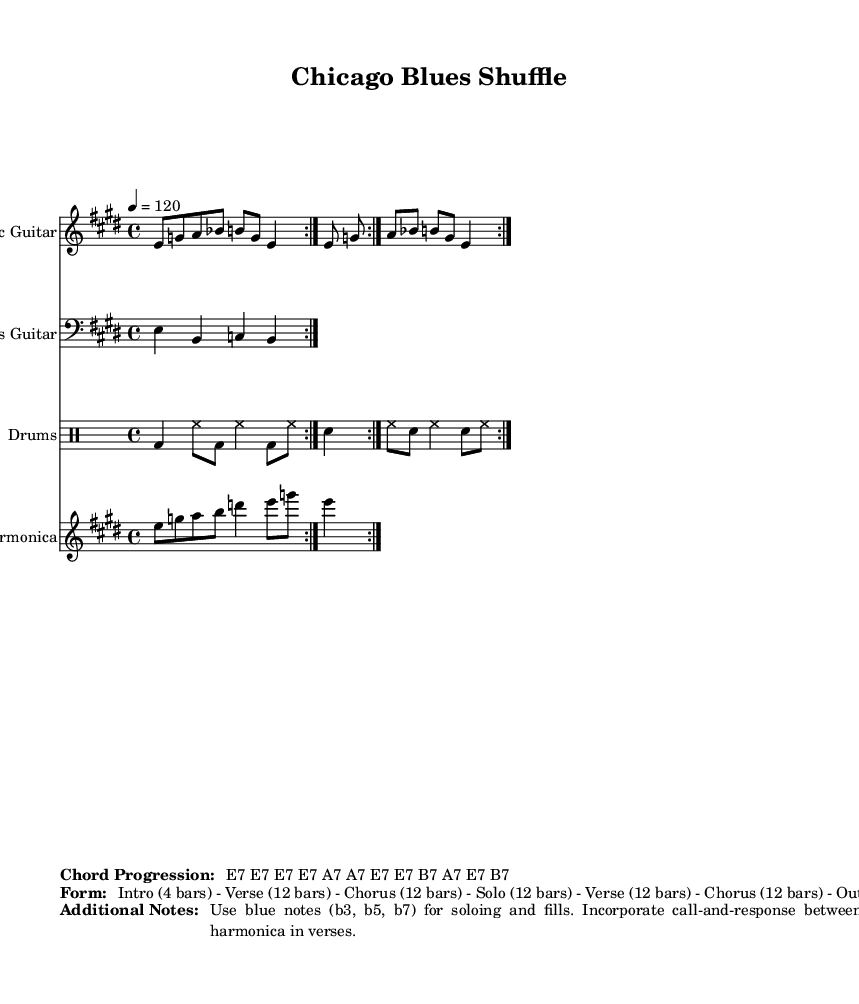What is the key signature of this music? The key signature indicates E major, which has four sharps (F#, C#, G#, D#). It's identified at the beginning of the sheet music.
Answer: E major What is the time signature of this music? The time signature shows 4/4, which means there are four beats per measure and the quarter note gets one beat. This is common in blues music.
Answer: 4/4 What is the tempo marking of the piece? The tempo marking is 120, given in beats per minute, which signifies the speed at which the piece should be played.
Answer: 120 What chord progression is used in this piece? The chord progression indicated in the markup section shows a typical 12-bar blues structure: E7, A7, and B7 chords in a repeating pattern.
Answer: E7 A7 B7 What is the form of the music? The form details are in the markup section, indicating the structure and flow of the piece, which includes an intro, verses, a chorus, and a solo section.
Answer: Intro - Verse - Chorus - Solo - Verse - Chorus - Outro How many bars are in the solo section? The score specifically states that the solo section consists of 12 bars, just like the verses and choruses, which is a standard length in blues music.
Answer: 12 bars What should musicians apply when soloing? The additional notes indicate using blue notes (flattened third, fifth, and seventh) for soloing, which adds to the expressive quality of the blues.
Answer: Blue notes 